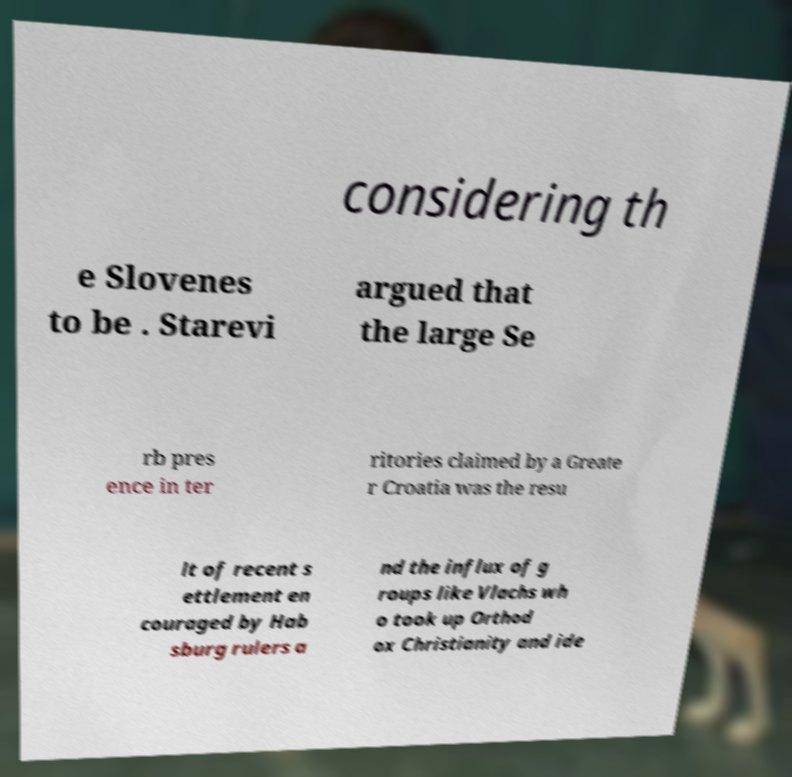Can you read and provide the text displayed in the image?This photo seems to have some interesting text. Can you extract and type it out for me? considering th e Slovenes to be . Starevi argued that the large Se rb pres ence in ter ritories claimed by a Greate r Croatia was the resu lt of recent s ettlement en couraged by Hab sburg rulers a nd the influx of g roups like Vlachs wh o took up Orthod ox Christianity and ide 